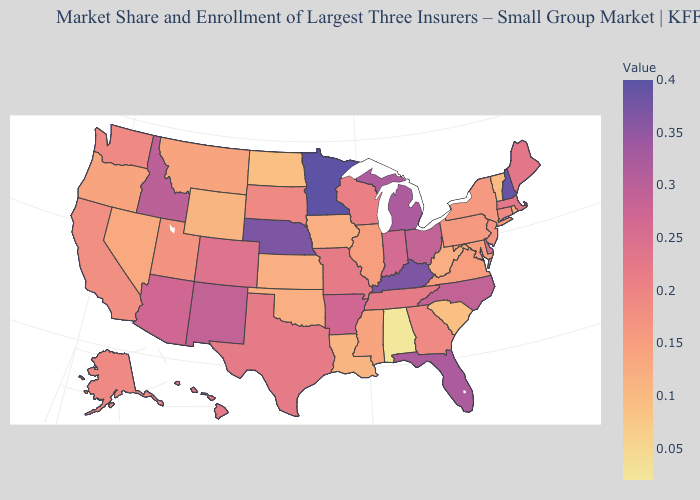Does Washington have a lower value than North Carolina?
Give a very brief answer. Yes. Which states have the highest value in the USA?
Give a very brief answer. Minnesota. Among the states that border California , which have the lowest value?
Be succinct. Nevada. Which states have the lowest value in the South?
Write a very short answer. Alabama. Which states have the lowest value in the MidWest?
Keep it brief. North Dakota. 